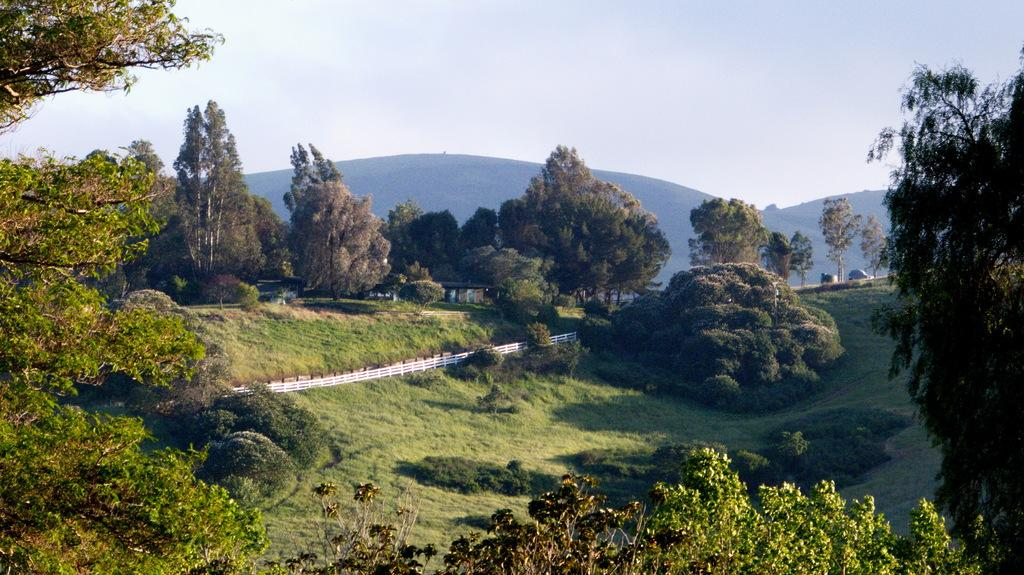What is the main feature of the image? The main feature of the image is the many trees. What type of vegetation surrounds the trees? The trees are surrounded by grass. What can be seen in the background of the image? The background of the image is the sky. How many pizzas are being served on the chair in the image? There are no pizzas or chairs present in the image; it features trees surrounded by grass with the sky as the background. 